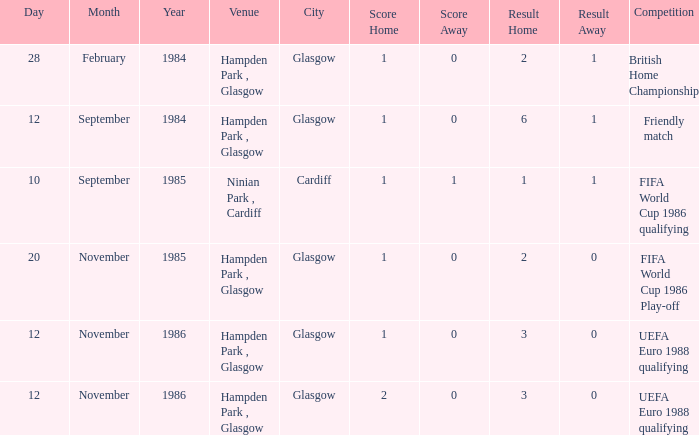Parse the table in full. {'header': ['Day', 'Month', 'Year', 'Venue', 'City', 'Score Home', 'Score Away', 'Result Home', 'Result Away', 'Competition'], 'rows': [['28', 'February', '1984', 'Hampden Park , Glasgow', 'Glasgow', '1', '0', '2', '1', 'British Home Championship'], ['12', 'September', '1984', 'Hampden Park , Glasgow', 'Glasgow', '1', '0', '6', '1', 'Friendly match'], ['10', 'September', '1985', 'Ninian Park , Cardiff', 'Cardiff', '1', '1', '1', '1', 'FIFA World Cup 1986 qualifying'], ['20', 'November', '1985', 'Hampden Park , Glasgow', 'Glasgow', '1', '0', '2', '0', 'FIFA World Cup 1986 Play-off'], ['12', 'November', '1986', 'Hampden Park , Glasgow', 'Glasgow', '1', '0', '3', '0', 'UEFA Euro 1988 qualifying'], ['12', 'November', '1986', 'Hampden Park , Glasgow', 'Glasgow', '2', '0', '3', '0', 'UEFA Euro 1988 qualifying']]} What is the Score of the Fifa World Cup 1986 Play-off Competition? 1–0. 